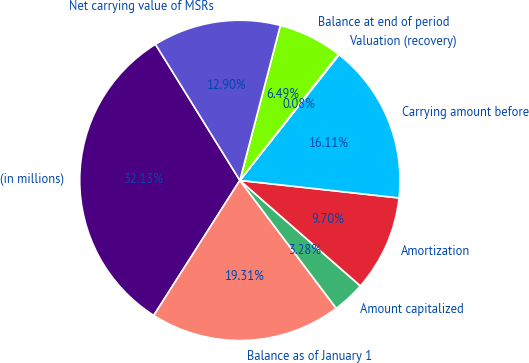Convert chart to OTSL. <chart><loc_0><loc_0><loc_500><loc_500><pie_chart><fcel>(in millions)<fcel>Balance as of January 1<fcel>Amount capitalized<fcel>Amortization<fcel>Carrying amount before<fcel>Valuation (recovery)<fcel>Balance at end of period<fcel>Net carrying value of MSRs<nl><fcel>32.13%<fcel>19.31%<fcel>3.28%<fcel>9.7%<fcel>16.11%<fcel>0.08%<fcel>6.49%<fcel>12.9%<nl></chart> 